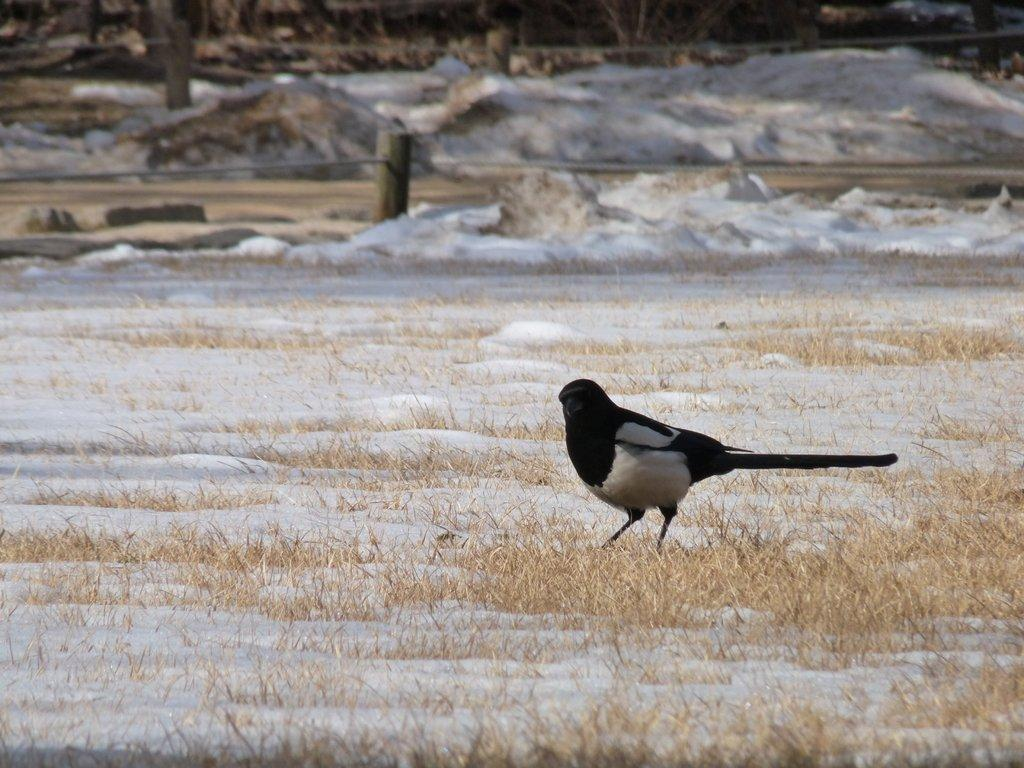What type of bird is in the image? There is a crow in the image. Where is the crow located? The crow is on grass. What color is the surface that the crow is standing on? The surface is white in color. What can be seen in the background of the image? There are trees in the background of the image. What object is present in the image that might be used for tying or securing? There is a rope in the image. What type of question is the crow asking in the image? There is no indication in the image that the crow is asking a question. --- Facts: 1. There is a person holding a camera in the image. 2. The person is standing on a bridge. 3. There is a river below the bridge. 4. The sky is visible in the image. 5. There are clouds in the sky. Absurd Topics: dance, piano, ocean Conversation: What is the person in the image holding? The person in the image is holding a camera. Where is the person standing in the image? The person is standing on a bridge. What can be seen below the bridge in the image? There is a river below the bridge. What is visible at the top of the image? The sky is visible in the image. What can be observed in the sky in the image? There are clouds in the sky. Reasoning: Let's think step by step in order to produce the conversation. We start by identifying the main subject in the image, which is the person holding a camera. Then, we expand the conversation to include details about the person's location, the presence of a river below the bridge, the visibility of the sky, and the presence of clouds. Each question is designed to elicit a specific detail about the image that is known from the provided facts. Absurd Question/Answer: Can you hear the person playing the piano in the image? There is no piano present in the image, so it cannot be heard. --- Facts: 1. There is a person sitting on a bench in the image. 2. The person is reading a book. 3. There is a tree behind the bench. 4. The ground is visible in the image. 5. There are flowers near the bench. Absurd Topics: parrot, bicycle, mountain Conversation: What is the person in the image doing? The person in the image is sitting on a bench and reading a book. Where is the person located in the image? The person is sitting on a bench. What can be seen behind the bench in the image? There is a tree behind the bench. What is visible at the bottom of the image? The ground is visible in the image. Q: 